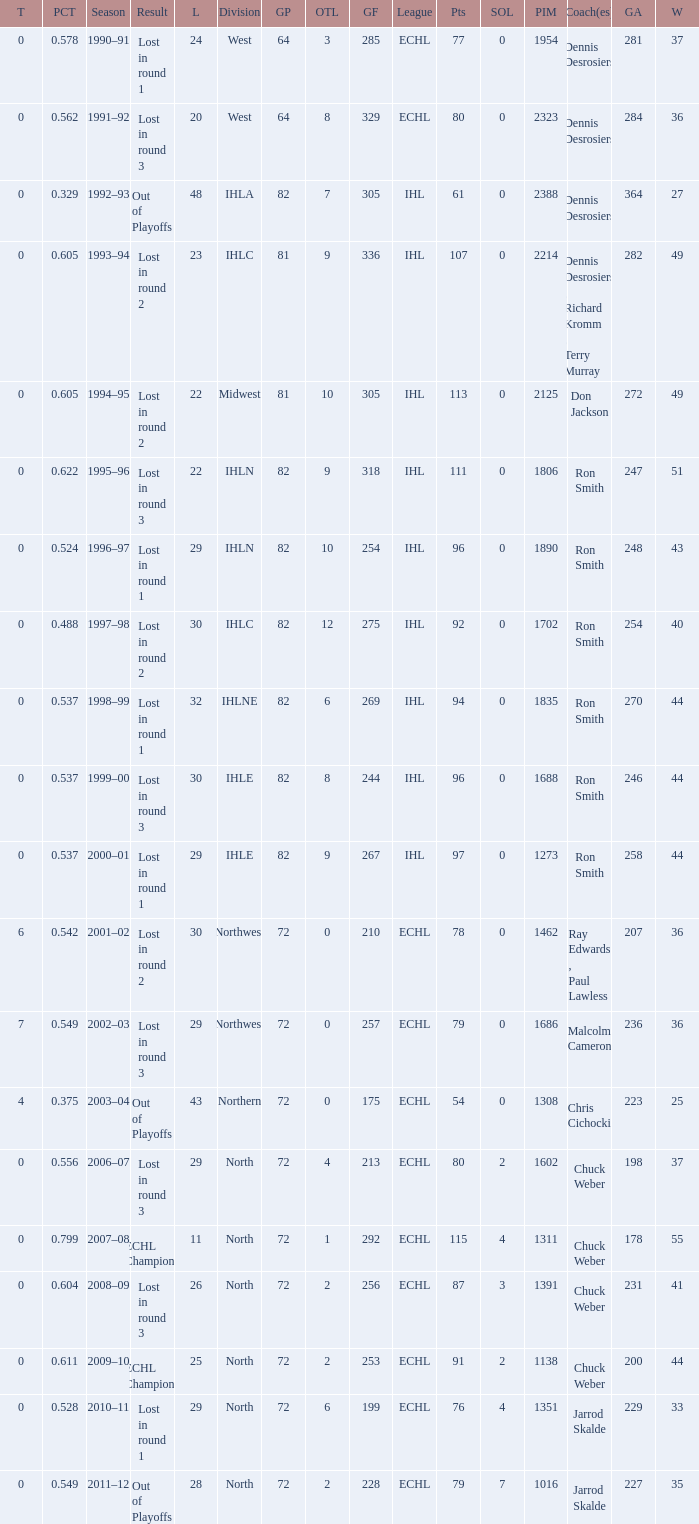What was the season where the team reached a GP of 244? 1999–00. 